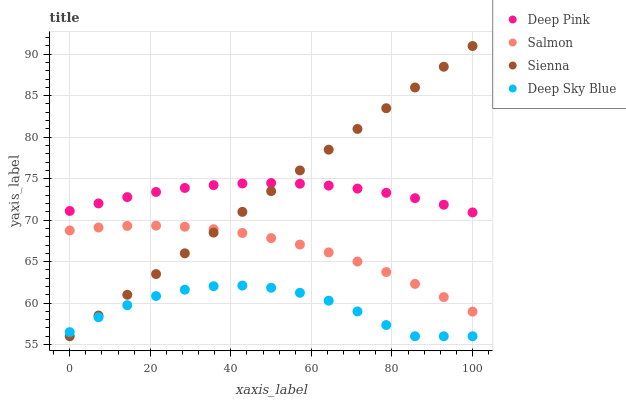Does Deep Sky Blue have the minimum area under the curve?
Answer yes or no. Yes. Does Sienna have the maximum area under the curve?
Answer yes or no. Yes. Does Deep Pink have the minimum area under the curve?
Answer yes or no. No. Does Deep Pink have the maximum area under the curve?
Answer yes or no. No. Is Sienna the smoothest?
Answer yes or no. Yes. Is Deep Sky Blue the roughest?
Answer yes or no. Yes. Is Deep Pink the smoothest?
Answer yes or no. No. Is Deep Pink the roughest?
Answer yes or no. No. Does Sienna have the lowest value?
Answer yes or no. Yes. Does Salmon have the lowest value?
Answer yes or no. No. Does Sienna have the highest value?
Answer yes or no. Yes. Does Deep Pink have the highest value?
Answer yes or no. No. Is Deep Sky Blue less than Deep Pink?
Answer yes or no. Yes. Is Salmon greater than Deep Sky Blue?
Answer yes or no. Yes. Does Deep Pink intersect Sienna?
Answer yes or no. Yes. Is Deep Pink less than Sienna?
Answer yes or no. No. Is Deep Pink greater than Sienna?
Answer yes or no. No. Does Deep Sky Blue intersect Deep Pink?
Answer yes or no. No. 